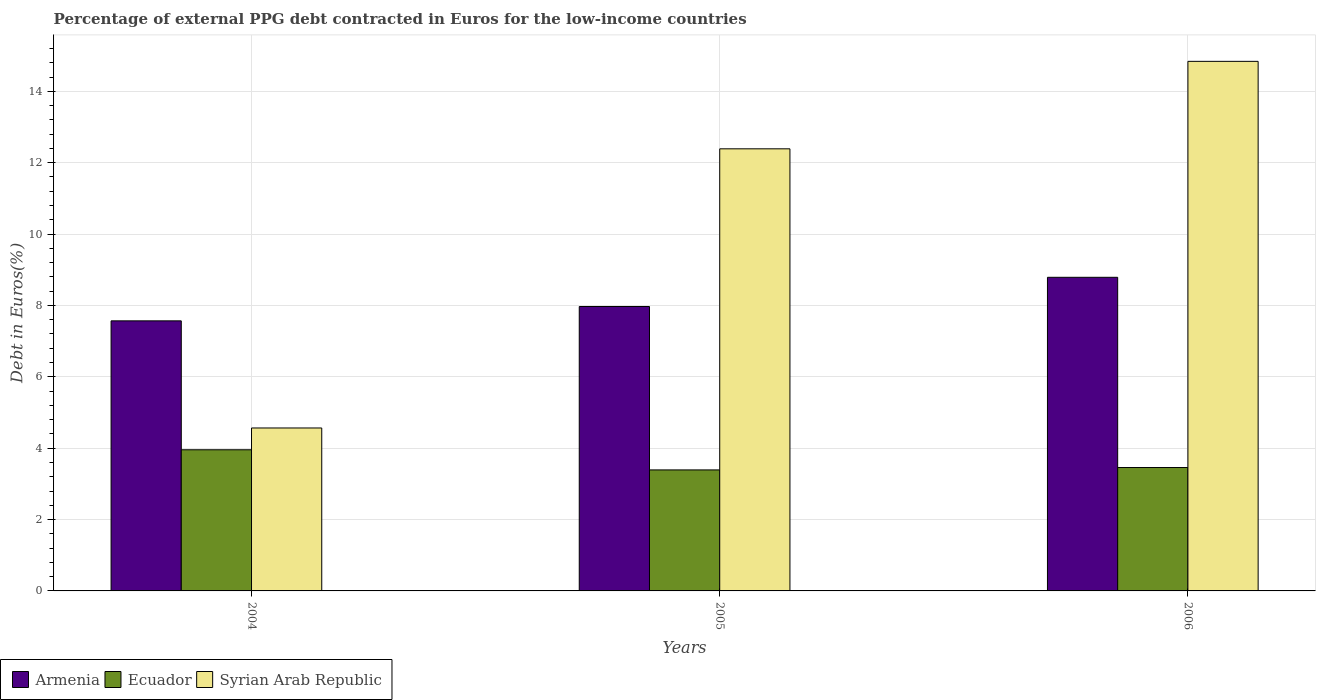How many different coloured bars are there?
Ensure brevity in your answer.  3. Are the number of bars per tick equal to the number of legend labels?
Ensure brevity in your answer.  Yes. What is the label of the 2nd group of bars from the left?
Your answer should be very brief. 2005. What is the percentage of external PPG debt contracted in Euros in Ecuador in 2006?
Offer a very short reply. 3.46. Across all years, what is the maximum percentage of external PPG debt contracted in Euros in Syrian Arab Republic?
Keep it short and to the point. 14.84. Across all years, what is the minimum percentage of external PPG debt contracted in Euros in Syrian Arab Republic?
Keep it short and to the point. 4.57. What is the total percentage of external PPG debt contracted in Euros in Armenia in the graph?
Offer a terse response. 24.33. What is the difference between the percentage of external PPG debt contracted in Euros in Syrian Arab Republic in 2005 and that in 2006?
Your answer should be compact. -2.45. What is the difference between the percentage of external PPG debt contracted in Euros in Syrian Arab Republic in 2005 and the percentage of external PPG debt contracted in Euros in Ecuador in 2004?
Ensure brevity in your answer.  8.43. What is the average percentage of external PPG debt contracted in Euros in Ecuador per year?
Your answer should be very brief. 3.6. In the year 2005, what is the difference between the percentage of external PPG debt contracted in Euros in Syrian Arab Republic and percentage of external PPG debt contracted in Euros in Armenia?
Offer a terse response. 4.42. In how many years, is the percentage of external PPG debt contracted in Euros in Ecuador greater than 4.4 %?
Provide a succinct answer. 0. What is the ratio of the percentage of external PPG debt contracted in Euros in Syrian Arab Republic in 2005 to that in 2006?
Your response must be concise. 0.83. Is the percentage of external PPG debt contracted in Euros in Armenia in 2004 less than that in 2005?
Your answer should be compact. Yes. Is the difference between the percentage of external PPG debt contracted in Euros in Syrian Arab Republic in 2004 and 2005 greater than the difference between the percentage of external PPG debt contracted in Euros in Armenia in 2004 and 2005?
Offer a very short reply. No. What is the difference between the highest and the second highest percentage of external PPG debt contracted in Euros in Syrian Arab Republic?
Your answer should be compact. 2.45. What is the difference between the highest and the lowest percentage of external PPG debt contracted in Euros in Armenia?
Your response must be concise. 1.22. In how many years, is the percentage of external PPG debt contracted in Euros in Armenia greater than the average percentage of external PPG debt contracted in Euros in Armenia taken over all years?
Your answer should be compact. 1. Is the sum of the percentage of external PPG debt contracted in Euros in Ecuador in 2004 and 2005 greater than the maximum percentage of external PPG debt contracted in Euros in Armenia across all years?
Offer a very short reply. No. What does the 1st bar from the left in 2004 represents?
Offer a very short reply. Armenia. What does the 3rd bar from the right in 2006 represents?
Give a very brief answer. Armenia. Is it the case that in every year, the sum of the percentage of external PPG debt contracted in Euros in Ecuador and percentage of external PPG debt contracted in Euros in Armenia is greater than the percentage of external PPG debt contracted in Euros in Syrian Arab Republic?
Provide a short and direct response. No. Where does the legend appear in the graph?
Make the answer very short. Bottom left. How are the legend labels stacked?
Offer a terse response. Horizontal. What is the title of the graph?
Offer a terse response. Percentage of external PPG debt contracted in Euros for the low-income countries. Does "East Asia (all income levels)" appear as one of the legend labels in the graph?
Make the answer very short. No. What is the label or title of the Y-axis?
Offer a terse response. Debt in Euros(%). What is the Debt in Euros(%) of Armenia in 2004?
Give a very brief answer. 7.57. What is the Debt in Euros(%) of Ecuador in 2004?
Provide a short and direct response. 3.96. What is the Debt in Euros(%) in Syrian Arab Republic in 2004?
Make the answer very short. 4.57. What is the Debt in Euros(%) in Armenia in 2005?
Ensure brevity in your answer.  7.97. What is the Debt in Euros(%) of Ecuador in 2005?
Offer a very short reply. 3.39. What is the Debt in Euros(%) in Syrian Arab Republic in 2005?
Provide a short and direct response. 12.39. What is the Debt in Euros(%) in Armenia in 2006?
Your answer should be very brief. 8.79. What is the Debt in Euros(%) in Ecuador in 2006?
Make the answer very short. 3.46. What is the Debt in Euros(%) of Syrian Arab Republic in 2006?
Ensure brevity in your answer.  14.84. Across all years, what is the maximum Debt in Euros(%) of Armenia?
Provide a short and direct response. 8.79. Across all years, what is the maximum Debt in Euros(%) of Ecuador?
Keep it short and to the point. 3.96. Across all years, what is the maximum Debt in Euros(%) of Syrian Arab Republic?
Provide a succinct answer. 14.84. Across all years, what is the minimum Debt in Euros(%) in Armenia?
Offer a terse response. 7.57. Across all years, what is the minimum Debt in Euros(%) in Ecuador?
Provide a succinct answer. 3.39. Across all years, what is the minimum Debt in Euros(%) of Syrian Arab Republic?
Offer a terse response. 4.57. What is the total Debt in Euros(%) in Armenia in the graph?
Provide a succinct answer. 24.33. What is the total Debt in Euros(%) in Ecuador in the graph?
Offer a terse response. 10.8. What is the total Debt in Euros(%) in Syrian Arab Republic in the graph?
Your answer should be compact. 31.79. What is the difference between the Debt in Euros(%) in Armenia in 2004 and that in 2005?
Provide a short and direct response. -0.4. What is the difference between the Debt in Euros(%) in Ecuador in 2004 and that in 2005?
Ensure brevity in your answer.  0.56. What is the difference between the Debt in Euros(%) in Syrian Arab Republic in 2004 and that in 2005?
Keep it short and to the point. -7.82. What is the difference between the Debt in Euros(%) of Armenia in 2004 and that in 2006?
Ensure brevity in your answer.  -1.22. What is the difference between the Debt in Euros(%) of Ecuador in 2004 and that in 2006?
Your answer should be very brief. 0.5. What is the difference between the Debt in Euros(%) in Syrian Arab Republic in 2004 and that in 2006?
Provide a short and direct response. -10.27. What is the difference between the Debt in Euros(%) of Armenia in 2005 and that in 2006?
Give a very brief answer. -0.82. What is the difference between the Debt in Euros(%) of Ecuador in 2005 and that in 2006?
Offer a very short reply. -0.07. What is the difference between the Debt in Euros(%) in Syrian Arab Republic in 2005 and that in 2006?
Provide a short and direct response. -2.45. What is the difference between the Debt in Euros(%) in Armenia in 2004 and the Debt in Euros(%) in Ecuador in 2005?
Provide a succinct answer. 4.18. What is the difference between the Debt in Euros(%) in Armenia in 2004 and the Debt in Euros(%) in Syrian Arab Republic in 2005?
Your answer should be compact. -4.82. What is the difference between the Debt in Euros(%) in Ecuador in 2004 and the Debt in Euros(%) in Syrian Arab Republic in 2005?
Give a very brief answer. -8.43. What is the difference between the Debt in Euros(%) in Armenia in 2004 and the Debt in Euros(%) in Ecuador in 2006?
Keep it short and to the point. 4.11. What is the difference between the Debt in Euros(%) of Armenia in 2004 and the Debt in Euros(%) of Syrian Arab Republic in 2006?
Provide a short and direct response. -7.27. What is the difference between the Debt in Euros(%) of Ecuador in 2004 and the Debt in Euros(%) of Syrian Arab Republic in 2006?
Give a very brief answer. -10.88. What is the difference between the Debt in Euros(%) in Armenia in 2005 and the Debt in Euros(%) in Ecuador in 2006?
Provide a short and direct response. 4.51. What is the difference between the Debt in Euros(%) of Armenia in 2005 and the Debt in Euros(%) of Syrian Arab Republic in 2006?
Ensure brevity in your answer.  -6.87. What is the difference between the Debt in Euros(%) of Ecuador in 2005 and the Debt in Euros(%) of Syrian Arab Republic in 2006?
Keep it short and to the point. -11.45. What is the average Debt in Euros(%) in Armenia per year?
Keep it short and to the point. 8.11. What is the average Debt in Euros(%) in Ecuador per year?
Make the answer very short. 3.6. What is the average Debt in Euros(%) of Syrian Arab Republic per year?
Make the answer very short. 10.6. In the year 2004, what is the difference between the Debt in Euros(%) in Armenia and Debt in Euros(%) in Ecuador?
Keep it short and to the point. 3.61. In the year 2004, what is the difference between the Debt in Euros(%) of Armenia and Debt in Euros(%) of Syrian Arab Republic?
Give a very brief answer. 3. In the year 2004, what is the difference between the Debt in Euros(%) of Ecuador and Debt in Euros(%) of Syrian Arab Republic?
Make the answer very short. -0.61. In the year 2005, what is the difference between the Debt in Euros(%) of Armenia and Debt in Euros(%) of Ecuador?
Provide a short and direct response. 4.58. In the year 2005, what is the difference between the Debt in Euros(%) in Armenia and Debt in Euros(%) in Syrian Arab Republic?
Provide a succinct answer. -4.42. In the year 2005, what is the difference between the Debt in Euros(%) of Ecuador and Debt in Euros(%) of Syrian Arab Republic?
Give a very brief answer. -9. In the year 2006, what is the difference between the Debt in Euros(%) of Armenia and Debt in Euros(%) of Ecuador?
Offer a terse response. 5.33. In the year 2006, what is the difference between the Debt in Euros(%) of Armenia and Debt in Euros(%) of Syrian Arab Republic?
Offer a terse response. -6.05. In the year 2006, what is the difference between the Debt in Euros(%) of Ecuador and Debt in Euros(%) of Syrian Arab Republic?
Your answer should be very brief. -11.38. What is the ratio of the Debt in Euros(%) in Armenia in 2004 to that in 2005?
Your response must be concise. 0.95. What is the ratio of the Debt in Euros(%) of Ecuador in 2004 to that in 2005?
Give a very brief answer. 1.17. What is the ratio of the Debt in Euros(%) of Syrian Arab Republic in 2004 to that in 2005?
Your response must be concise. 0.37. What is the ratio of the Debt in Euros(%) in Armenia in 2004 to that in 2006?
Offer a terse response. 0.86. What is the ratio of the Debt in Euros(%) in Ecuador in 2004 to that in 2006?
Ensure brevity in your answer.  1.14. What is the ratio of the Debt in Euros(%) of Syrian Arab Republic in 2004 to that in 2006?
Make the answer very short. 0.31. What is the ratio of the Debt in Euros(%) in Armenia in 2005 to that in 2006?
Your answer should be compact. 0.91. What is the ratio of the Debt in Euros(%) of Ecuador in 2005 to that in 2006?
Your response must be concise. 0.98. What is the ratio of the Debt in Euros(%) of Syrian Arab Republic in 2005 to that in 2006?
Provide a short and direct response. 0.83. What is the difference between the highest and the second highest Debt in Euros(%) in Armenia?
Offer a terse response. 0.82. What is the difference between the highest and the second highest Debt in Euros(%) of Ecuador?
Offer a terse response. 0.5. What is the difference between the highest and the second highest Debt in Euros(%) of Syrian Arab Republic?
Offer a very short reply. 2.45. What is the difference between the highest and the lowest Debt in Euros(%) of Armenia?
Offer a terse response. 1.22. What is the difference between the highest and the lowest Debt in Euros(%) of Ecuador?
Ensure brevity in your answer.  0.56. What is the difference between the highest and the lowest Debt in Euros(%) of Syrian Arab Republic?
Ensure brevity in your answer.  10.27. 